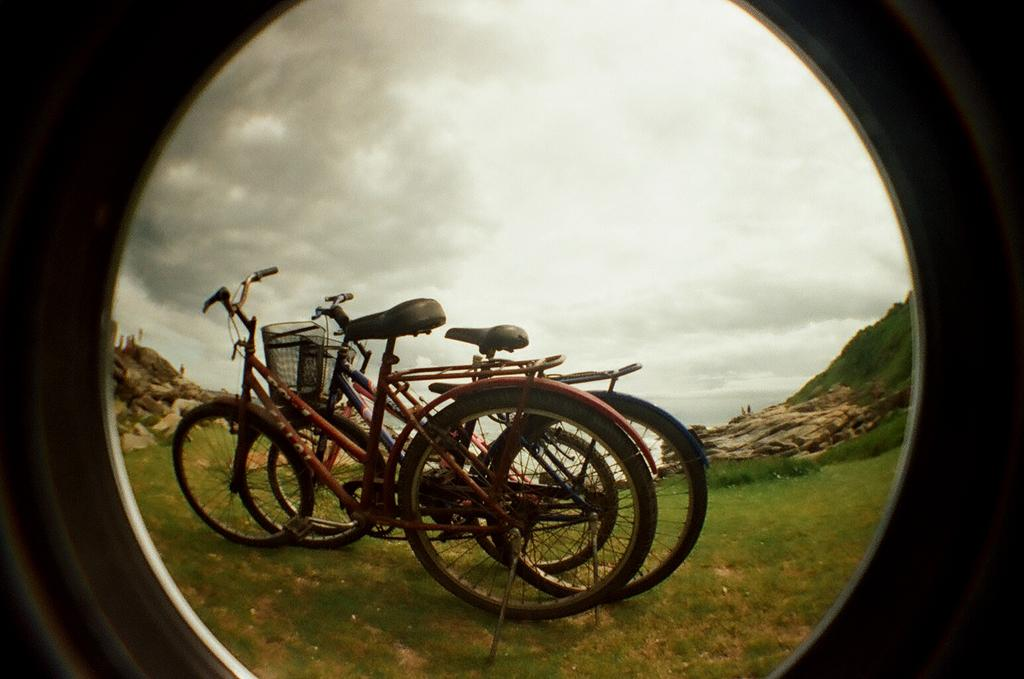What can be seen on the ground in the image? There are two bicycles on the ground in the image. What type of natural elements are present in the image? There are rocks and grass in the image. What is visible in the background of the image? The sky is visible in the background of the image. Where is the judge standing in the image? There is no judge present in the image. What type of train can be seen passing by in the image? There is no train visible in the image. 